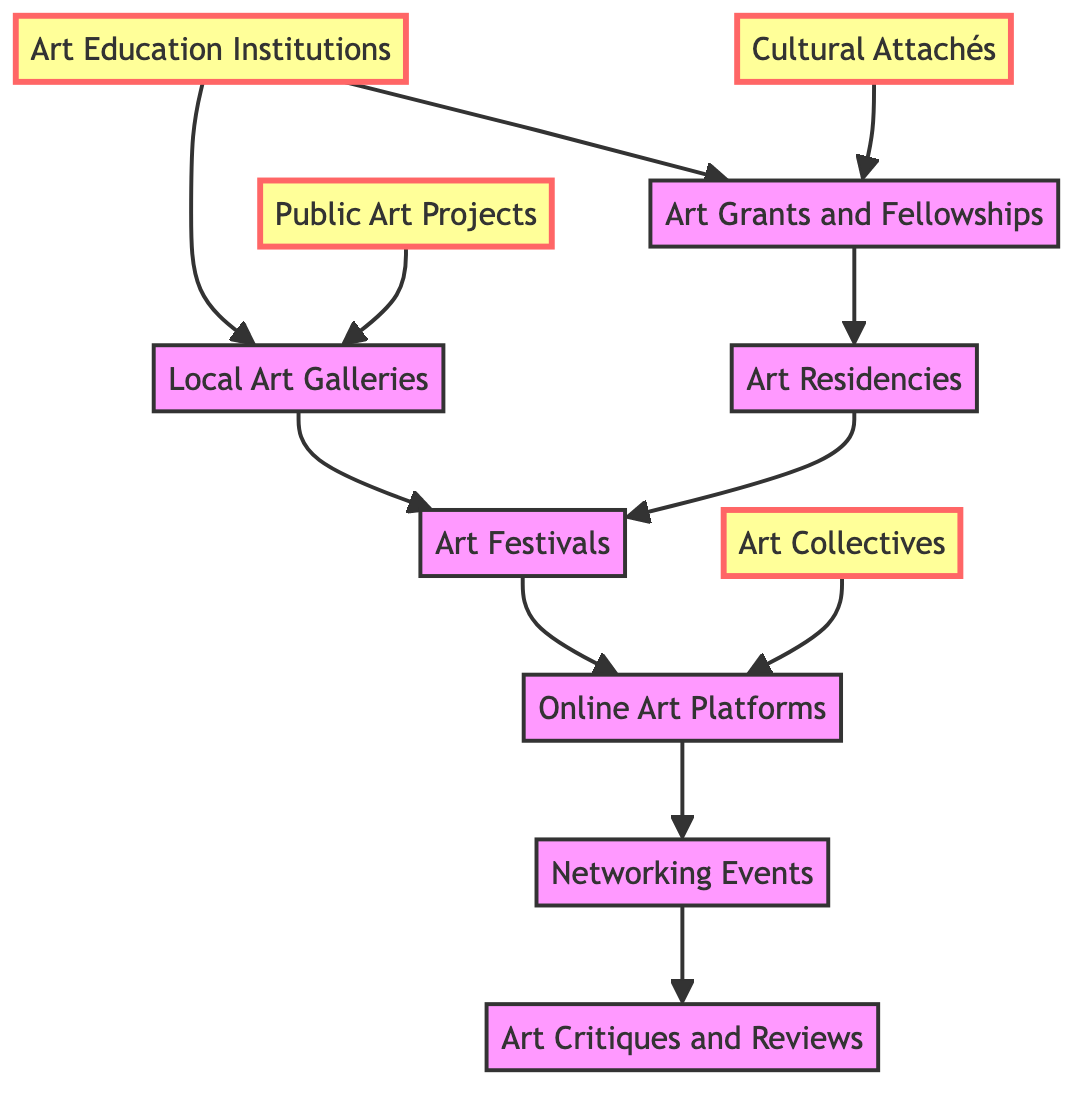What are the two primary nodes connected to Art Education Institutions? The diagram shows that Art Education Institutions are connected to Local Art Galleries and Art Grants and Fellowships. These connections are represented as edges leading to both nodes.
Answer: Local Art Galleries, Art Grants and Fellowships How many nodes are in the diagram? The diagram lists a total of 11 nodes representing different elements related to artist career pathways.
Answer: 11 Which node is a destination after Art Festivals? According to the diagram, Art Festivals connect to Online Art Platforms, indicating that Online Art Platforms is the next destination in this pathway.
Answer: Online Art Platforms What is the direct connection from Cultural Attachés? The diagram clearly indicates that Cultural Attachés has a direct connection to Art Grants and Fellowships. This means Cultural Attachés can assist or influence opportunities related to art grants.
Answer: Art Grants and Fellowships What is the relationship chain from Art Collectives to Networking Events? Starting from Art Collectives, the only direct route leads to Online Art Platforms, then to Networking Events. This indicates a pathway where involvement in art collectives can lead to opportunities on online platforms which further lead to networking events.
Answer: Through Online Art Platforms Which node receives a direct connection from Public Art Projects? The diagram shows that Public Art Projects connect directly to Local Art Galleries, establishing that works from public projects can be showcased or supported by galleries.
Answer: Local Art Galleries How many edges are outgoing from Online Art Platforms? By examining the connections, Online Art Platforms has two outgoing edges leading to Networking Events and Art Collectives. This indicates it serves as a starting point for multiple pathways.
Answer: 2 What is the purpose of Art Residencies in the diagram's context? The diagram shows a connection where Art Grants and Fellowships lead to Art Residencies, which indicates that they likely serve as a means of support or development for artists based on funding opportunities.
Answer: Pathway support Which node directly connects to both Art Festivals and Networking Events? The diagram indicates that only Online Art Platforms connects via an edge to both Art Festivals and Networking Events, making it a central point of opportunity for artists looking to expand their reach.
Answer: Online Art Platforms 